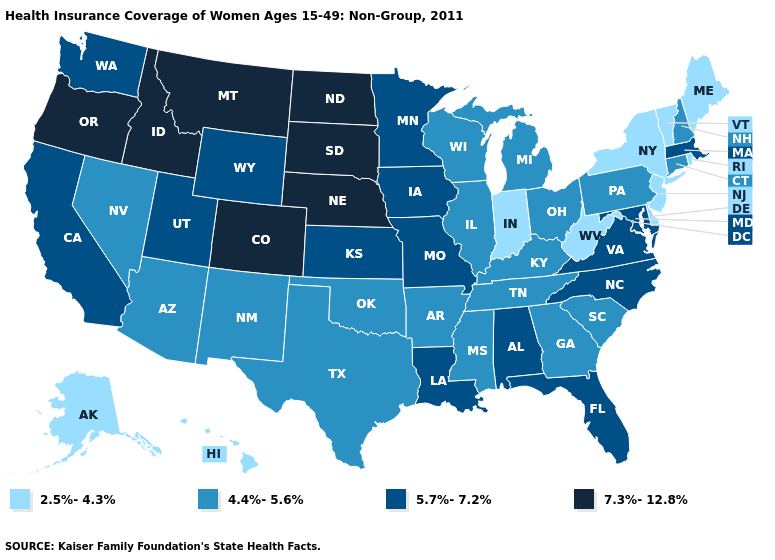What is the value of Illinois?
Write a very short answer. 4.4%-5.6%. Does New York have the same value as New Hampshire?
Short answer required. No. Which states have the highest value in the USA?
Short answer required. Colorado, Idaho, Montana, Nebraska, North Dakota, Oregon, South Dakota. What is the lowest value in the West?
Concise answer only. 2.5%-4.3%. Name the states that have a value in the range 7.3%-12.8%?
Short answer required. Colorado, Idaho, Montana, Nebraska, North Dakota, Oregon, South Dakota. Does Connecticut have the highest value in the Northeast?
Be succinct. No. Which states have the lowest value in the USA?
Give a very brief answer. Alaska, Delaware, Hawaii, Indiana, Maine, New Jersey, New York, Rhode Island, Vermont, West Virginia. What is the lowest value in the Northeast?
Keep it brief. 2.5%-4.3%. Among the states that border Maryland , which have the lowest value?
Concise answer only. Delaware, West Virginia. What is the value of Delaware?
Answer briefly. 2.5%-4.3%. What is the highest value in states that border Idaho?
Write a very short answer. 7.3%-12.8%. Among the states that border Massachusetts , does New York have the lowest value?
Answer briefly. Yes. What is the value of Washington?
Keep it brief. 5.7%-7.2%. Name the states that have a value in the range 2.5%-4.3%?
Answer briefly. Alaska, Delaware, Hawaii, Indiana, Maine, New Jersey, New York, Rhode Island, Vermont, West Virginia. What is the value of Florida?
Give a very brief answer. 5.7%-7.2%. 